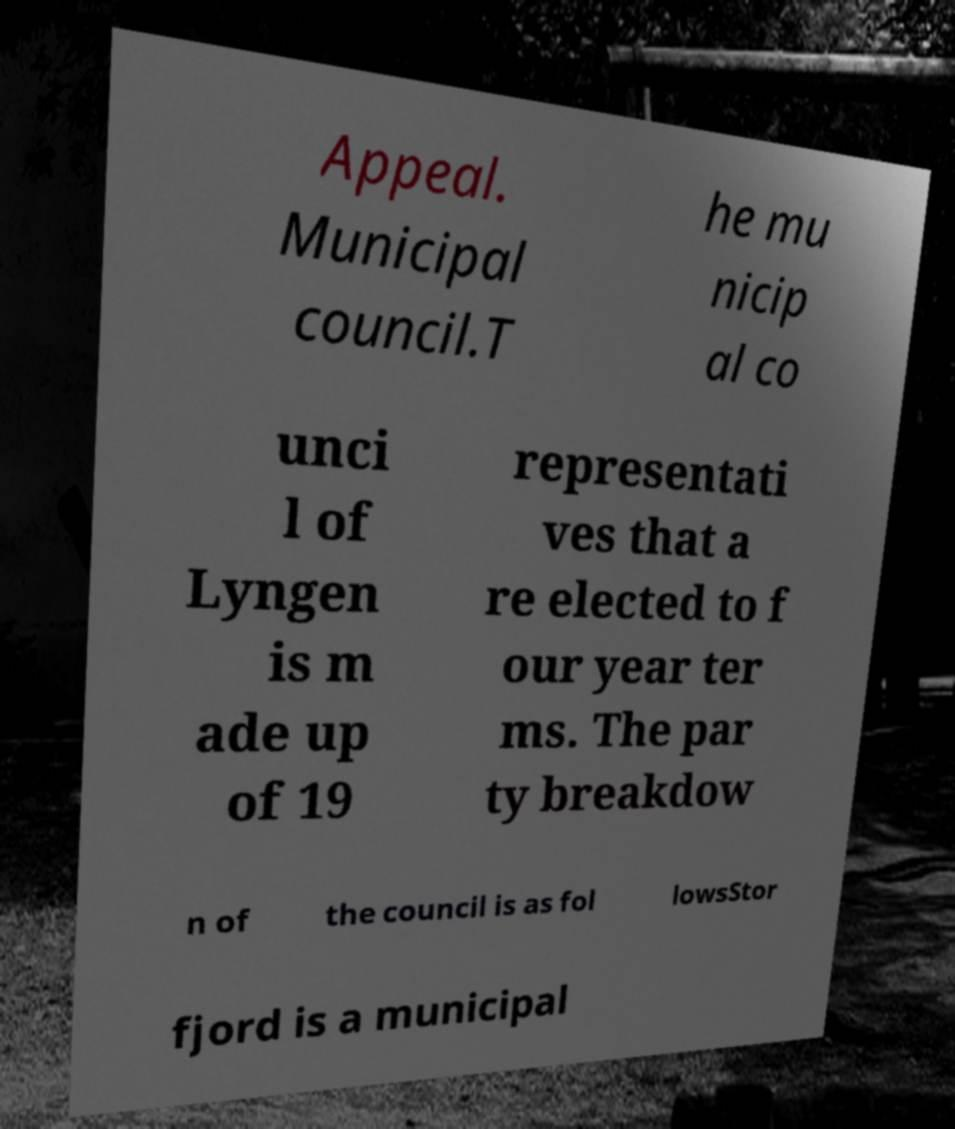Please read and relay the text visible in this image. What does it say? Appeal. Municipal council.T he mu nicip al co unci l of Lyngen is m ade up of 19 representati ves that a re elected to f our year ter ms. The par ty breakdow n of the council is as fol lowsStor fjord is a municipal 